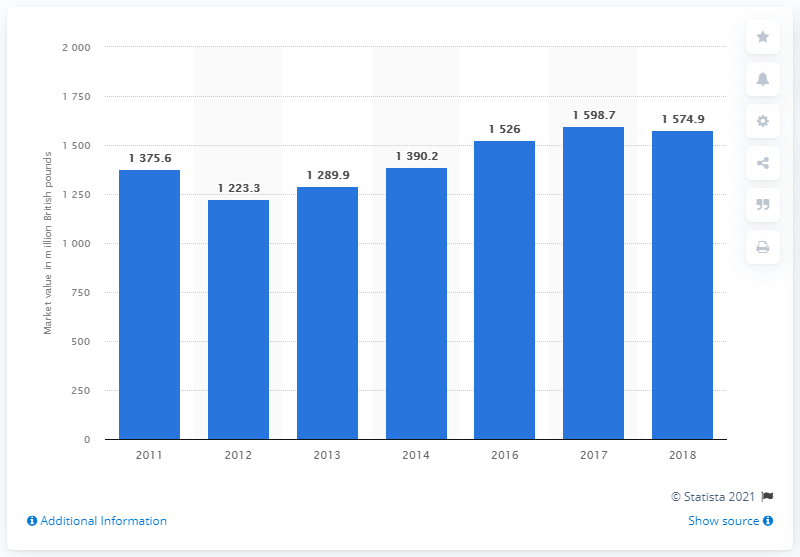List a handful of essential elements in this visual. In 2018, the market value of greeting cards in the UK was 1,574.9 million pounds. 